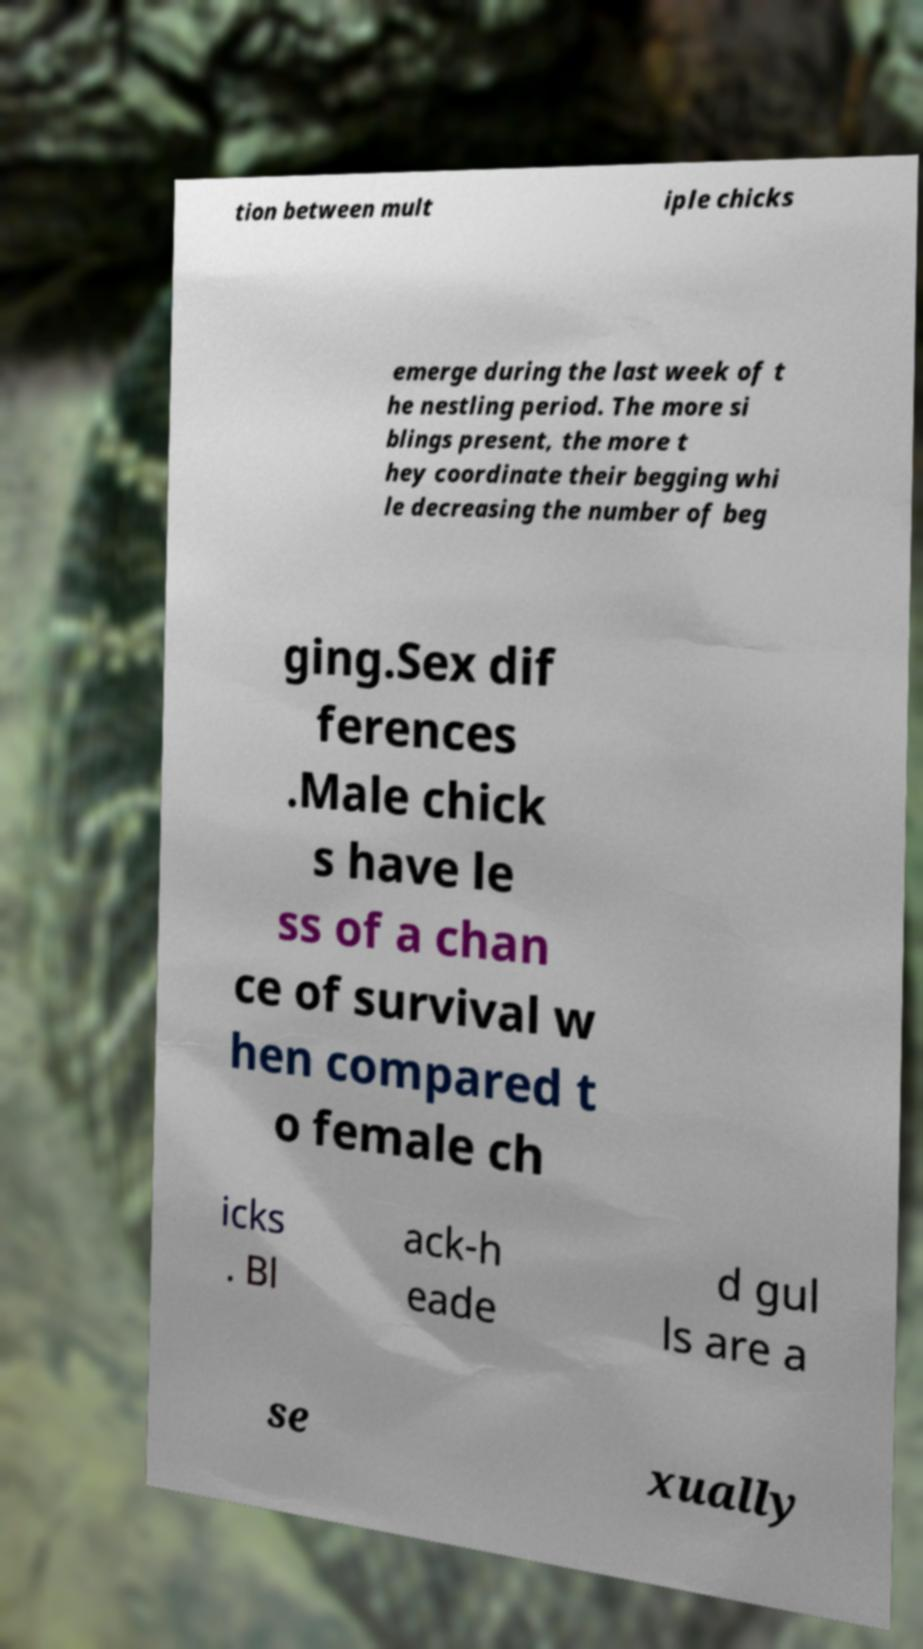Can you accurately transcribe the text from the provided image for me? tion between mult iple chicks emerge during the last week of t he nestling period. The more si blings present, the more t hey coordinate their begging whi le decreasing the number of beg ging.Sex dif ferences .Male chick s have le ss of a chan ce of survival w hen compared t o female ch icks . Bl ack-h eade d gul ls are a se xually 